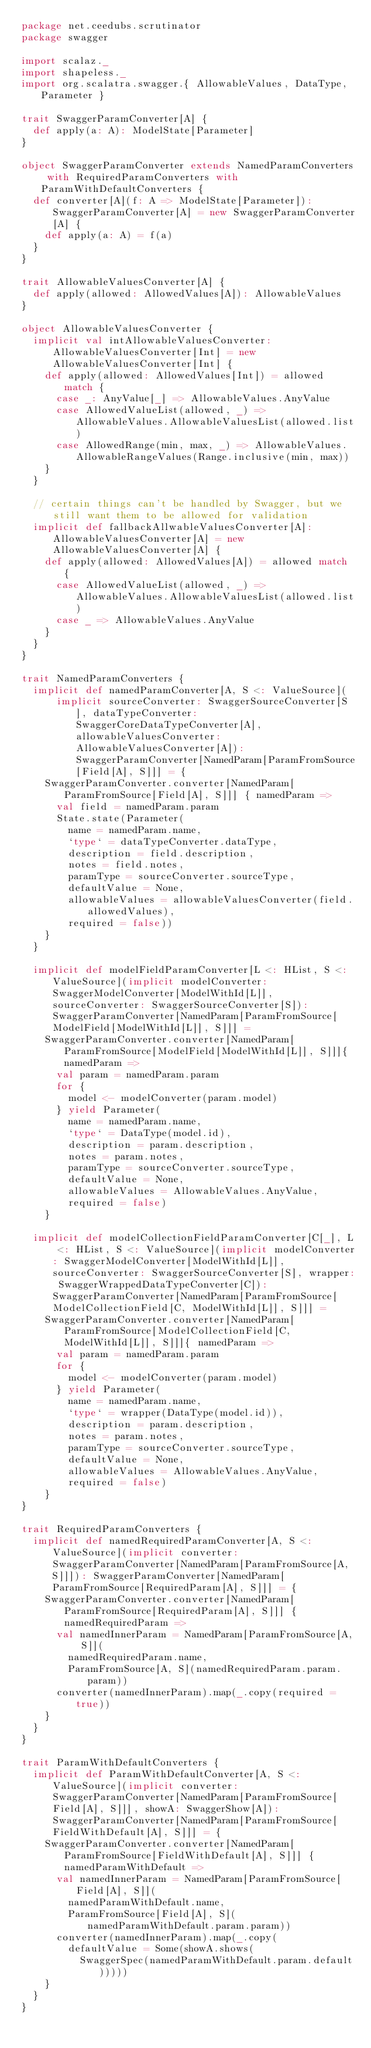Convert code to text. <code><loc_0><loc_0><loc_500><loc_500><_Scala_>package net.ceedubs.scrutinator
package swagger

import scalaz._
import shapeless._
import org.scalatra.swagger.{ AllowableValues, DataType, Parameter }

trait SwaggerParamConverter[A] {
  def apply(a: A): ModelState[Parameter]
}

object SwaggerParamConverter extends NamedParamConverters with RequiredParamConverters with ParamWithDefaultConverters {
  def converter[A](f: A => ModelState[Parameter]): SwaggerParamConverter[A] = new SwaggerParamConverter[A] {
    def apply(a: A) = f(a)
  }
}

trait AllowableValuesConverter[A] {
  def apply(allowed: AllowedValues[A]): AllowableValues
}

object AllowableValuesConverter {
  implicit val intAllowableValuesConverter: AllowableValuesConverter[Int] = new AllowableValuesConverter[Int] {
    def apply(allowed: AllowedValues[Int]) = allowed match {
      case _: AnyValue[_] => AllowableValues.AnyValue
      case AllowedValueList(allowed, _) => AllowableValues.AllowableValuesList(allowed.list)
      case AllowedRange(min, max, _) => AllowableValues.AllowableRangeValues(Range.inclusive(min, max))
    }
  }

  // certain things can't be handled by Swagger, but we still want them to be allowed for validation
  implicit def fallbackAllwableValuesConverter[A]: AllowableValuesConverter[A] = new AllowableValuesConverter[A] {
    def apply(allowed: AllowedValues[A]) = allowed match {
      case AllowedValueList(allowed, _) => AllowableValues.AllowableValuesList(allowed.list)
      case _ => AllowableValues.AnyValue
    }
  }
}

trait NamedParamConverters {
  implicit def namedParamConverter[A, S <: ValueSource](
      implicit sourceConverter: SwaggerSourceConverter[S], dataTypeConverter: SwaggerCoreDataTypeConverter[A], allowableValuesConverter: AllowableValuesConverter[A]): SwaggerParamConverter[NamedParam[ParamFromSource[Field[A], S]]] = {
    SwaggerParamConverter.converter[NamedParam[ParamFromSource[Field[A], S]]] { namedParam =>
      val field = namedParam.param
      State.state(Parameter(
        name = namedParam.name,
        `type` = dataTypeConverter.dataType,
        description = field.description,
        notes = field.notes,
        paramType = sourceConverter.sourceType,
        defaultValue = None,
        allowableValues = allowableValuesConverter(field.allowedValues),
        required = false))
    }
  }

  implicit def modelFieldParamConverter[L <: HList, S <: ValueSource](implicit modelConverter: SwaggerModelConverter[ModelWithId[L]], sourceConverter: SwaggerSourceConverter[S]): SwaggerParamConverter[NamedParam[ParamFromSource[ModelField[ModelWithId[L]], S]]] =
    SwaggerParamConverter.converter[NamedParam[ParamFromSource[ModelField[ModelWithId[L]], S]]]{ namedParam =>
      val param = namedParam.param
      for {
        model <- modelConverter(param.model)
      } yield Parameter(
        name = namedParam.name,
        `type` = DataType(model.id),
        description = param.description,
        notes = param.notes,
        paramType = sourceConverter.sourceType,
        defaultValue = None,
        allowableValues = AllowableValues.AnyValue,
        required = false)
    }

  implicit def modelCollectionFieldParamConverter[C[_], L <: HList, S <: ValueSource](implicit modelConverter: SwaggerModelConverter[ModelWithId[L]], sourceConverter: SwaggerSourceConverter[S], wrapper: SwaggerWrappedDataTypeConverter[C]): SwaggerParamConverter[NamedParam[ParamFromSource[ModelCollectionField[C, ModelWithId[L]], S]]] =
    SwaggerParamConverter.converter[NamedParam[ParamFromSource[ModelCollectionField[C, ModelWithId[L]], S]]]{ namedParam =>
      val param = namedParam.param
      for {
        model <- modelConverter(param.model)
      } yield Parameter(
        name = namedParam.name,
        `type` = wrapper(DataType(model.id)),
        description = param.description,
        notes = param.notes,
        paramType = sourceConverter.sourceType,
        defaultValue = None,
        allowableValues = AllowableValues.AnyValue,
        required = false)
    }
}

trait RequiredParamConverters {
  implicit def namedRequiredParamConverter[A, S <: ValueSource](implicit converter: SwaggerParamConverter[NamedParam[ParamFromSource[A, S]]]): SwaggerParamConverter[NamedParam[ParamFromSource[RequiredParam[A], S]]] = {
    SwaggerParamConverter.converter[NamedParam[ParamFromSource[RequiredParam[A], S]]] { namedRequiredParam =>
      val namedInnerParam = NamedParam[ParamFromSource[A, S]](
        namedRequiredParam.name,
        ParamFromSource[A, S](namedRequiredParam.param.param))
      converter(namedInnerParam).map(_.copy(required = true))
    }
  }
}

trait ParamWithDefaultConverters {
  implicit def ParamWithDefaultConverter[A, S <: ValueSource](implicit converter: SwaggerParamConverter[NamedParam[ParamFromSource[Field[A], S]]], showA: SwaggerShow[A]): SwaggerParamConverter[NamedParam[ParamFromSource[FieldWithDefault[A], S]]] = {
    SwaggerParamConverter.converter[NamedParam[ParamFromSource[FieldWithDefault[A], S]]] { namedParamWithDefault =>
      val namedInnerParam = NamedParam[ParamFromSource[Field[A], S]](
        namedParamWithDefault.name,
        ParamFromSource[Field[A], S](namedParamWithDefault.param.param))
      converter(namedInnerParam).map(_.copy(
        defaultValue = Some(showA.shows(
          SwaggerSpec(namedParamWithDefault.param.default)))))
    }
  }
}
</code> 